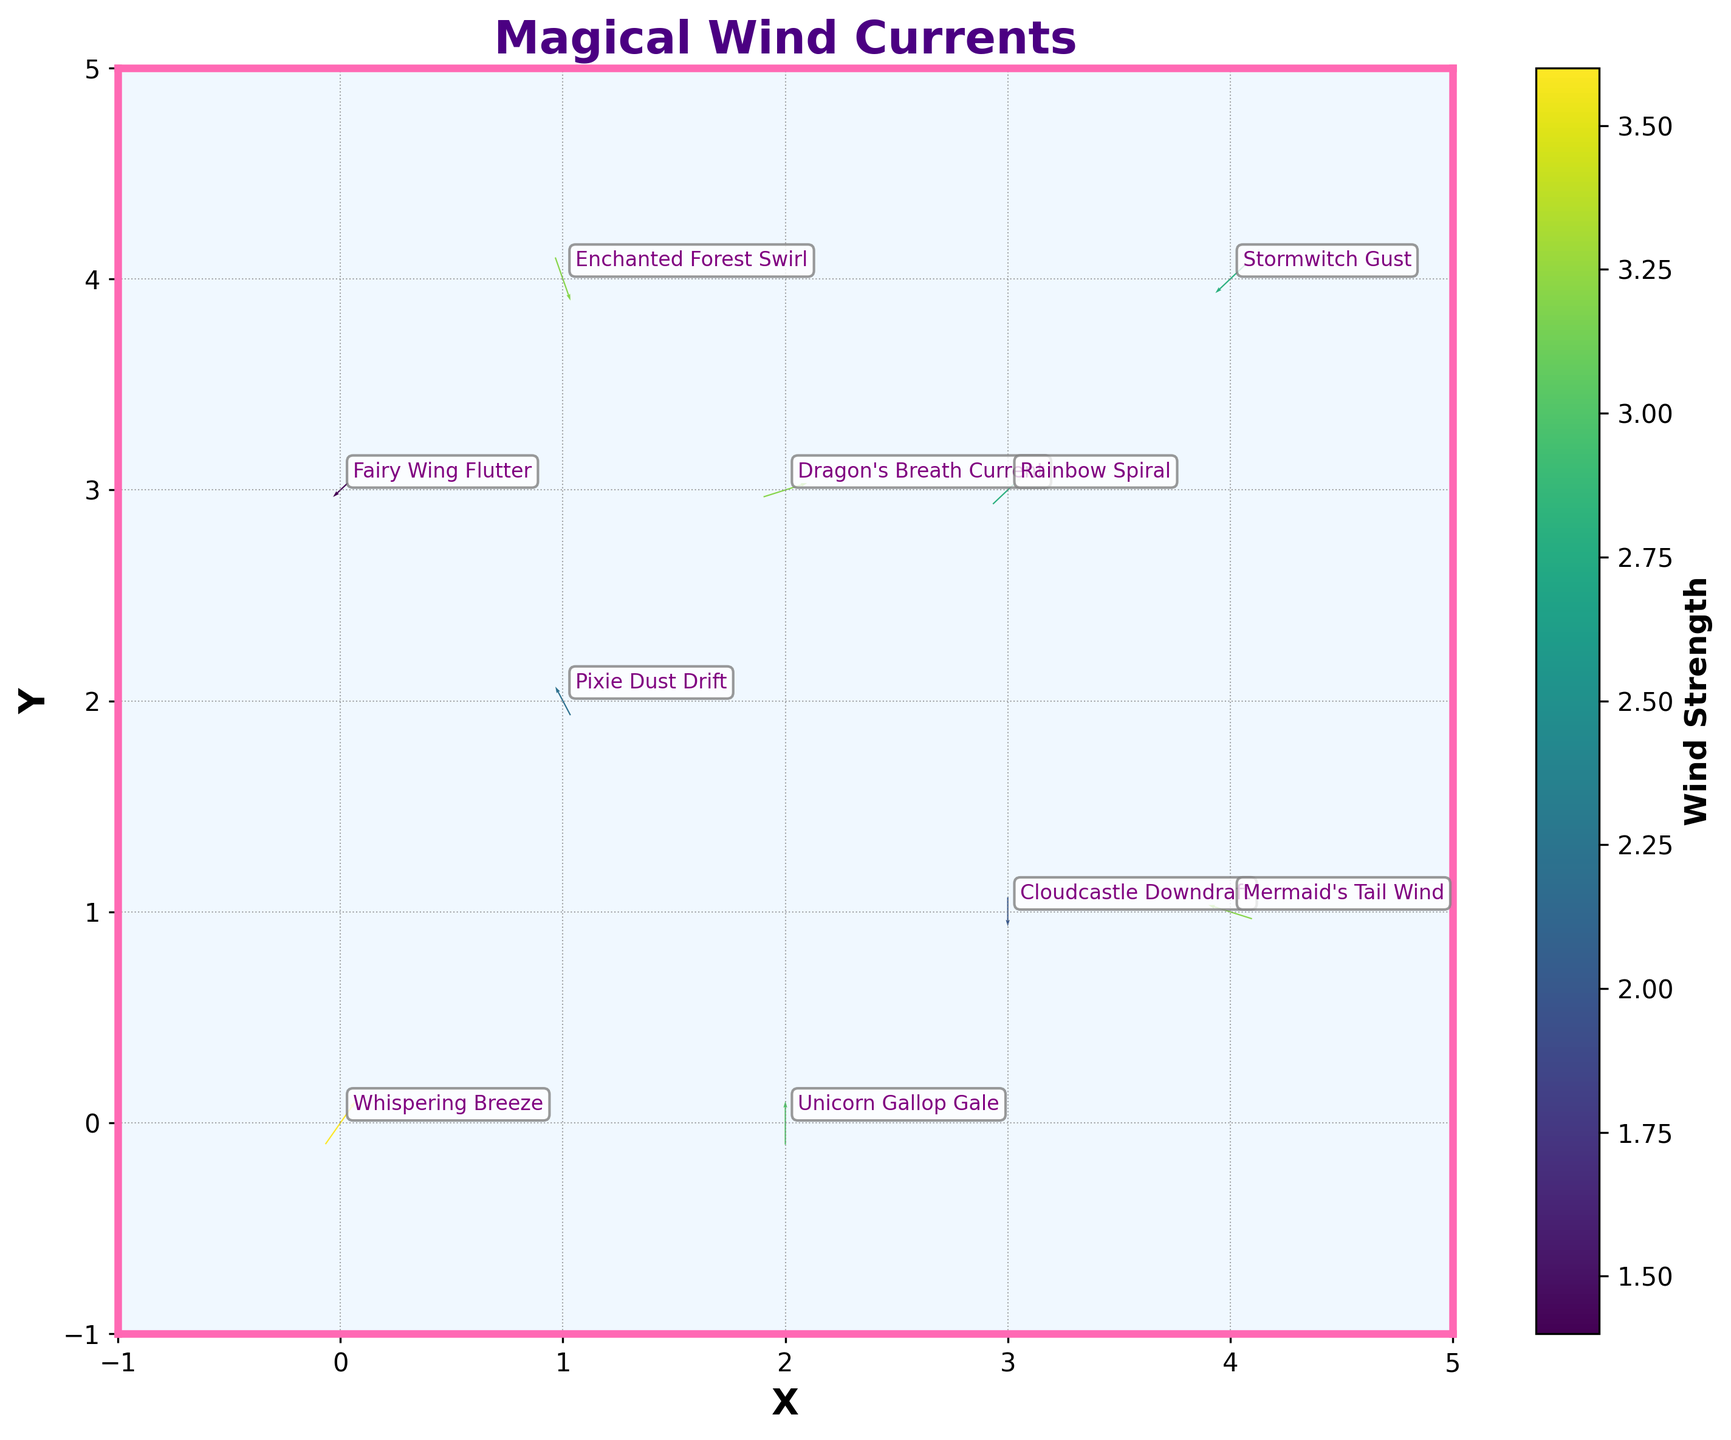What is the title of the plot? The title is located at the top of the plot and typically describes the main focus or context of the visualized data. In this plot, the title is "Magical Wind Currents," indicating that it visualizes wind patterns in a magical world.
Answer: Magical Wind Currents What are the x and y values for the "Dragon's Breath Current"? The x and y values can be found by looking at the coordinates next to the description "Dragon's Breath Current." According to the data, it is located at (2, 3).
Answer: (2, 3) Which wind pattern has the highest strength? The strength or magnitude of the wind patterns is shown by the color intensity in the plot. The description with the highest magnitude from the data table is "Whispering Breeze" with a magnitude of 3.6.
Answer: Whispering Breeze Which wind patterns have an upward direction (positive y-component)? Winds with a positive y-component are those with a vector pointing upwards on the plot. By examining the data, we find "Whispering Breeze," "Pixie Dust Drift," "Dragon's Breath Current," "Rainbow Spiral," "Mermaid's Tail Wind," and "Unicorn Gallop Gale" have positive y-components.
Answer: Whispering Breeze, Pixie Dust Drift, Dragon's Breath Current, Rainbow Spiral, Mermaid's Tail Wind, Unicorn Gallop Gale What is the x-y direction of the "Stormwitch Gust"? The x-y direction of "Stormwitch Gust" can be identified by its vector components. The vector points to (-2, -2), indicating it moves left (negative x) and downward (negative y).
Answer: Left and Downward Which wind pattern is located at the highest y-coordinate? By examining the y-coordinates of all wind patterns, the highest y-coordinates are at (4, 4) and (1, 4). Comparing these coordinates, "Enchanted Forest Swirl" and "Stormwitch Gust" are at the highest y-coordinate of 4.
Answer: Stormwitch Gust, Enchanted Forest Swirl What is the average x-coordinate of all wind patterns? Sum up all x-coordinates: 0 + 1 + 3 + 2 + 4 + 1 + 3 + 4 + 2 + 0 = 20. There are 10 data points, so the average is 20 / 10.
Answer: 2 Which wind pattern flows directly downward? A vector with a direction purely downward will have an x-component of 0 and a negative y-component. According to the data, "Cloudcastle Downdraft" fits this criterion with (0, -2).
Answer: Cloudcastle Downdraft Which wind pattern has a zero x-component in its wind direction? Vectors with a zero x-component (u = 0) are purely vertical. According to the data, "Cloudcastle Downdraft" and "Unicorn Gallop Gale" have zero x-components.
Answer: Cloudcastle Downdraft, Unicorn Gallop Gale 